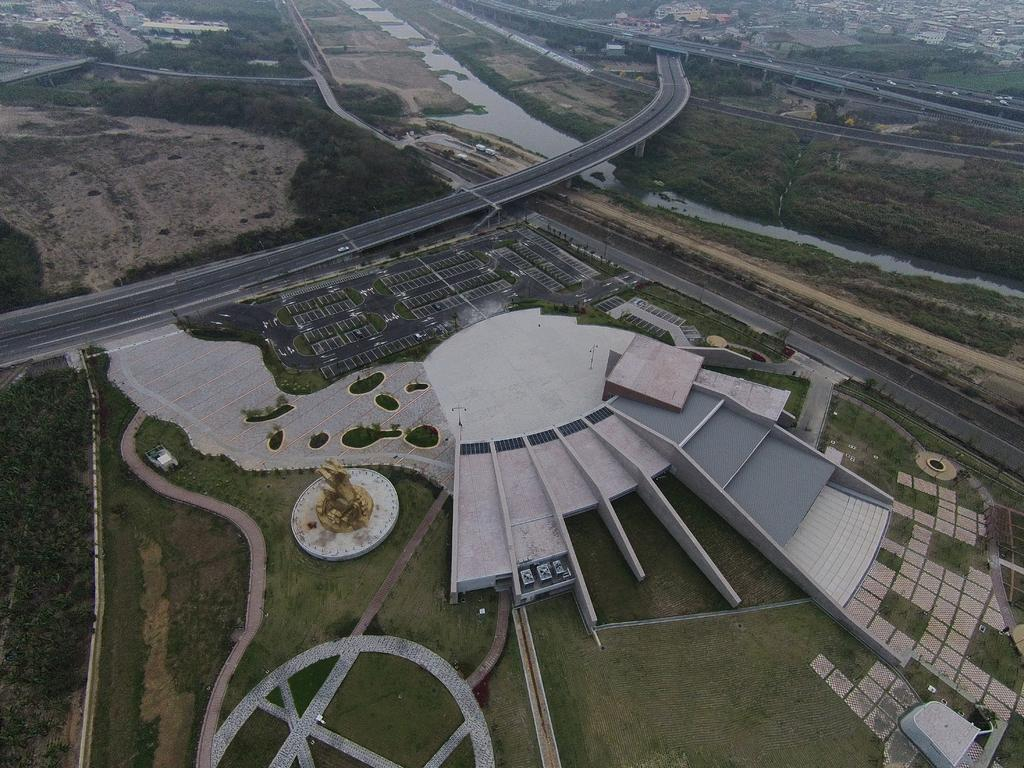What is the main feature of the image? There is a road in the image. What is happening on the road? There are vehicles on the road. What type of structure can be seen in the image? There is a building in the image. Can you describe the surrounding environment? There is a path, grass, trees, and water visible in the image. What type of drug can be seen in the image? There is no drug present in the image. Can you describe the harbor in the image? There is no harbor present in the image. 